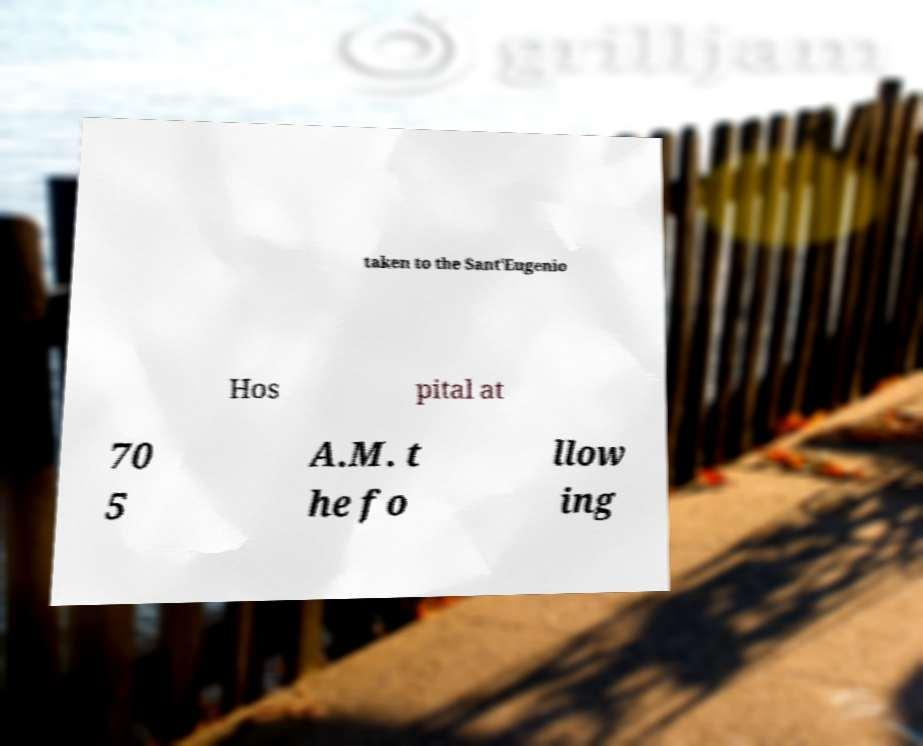There's text embedded in this image that I need extracted. Can you transcribe it verbatim? taken to the Sant'Eugenio Hos pital at 70 5 A.M. t he fo llow ing 